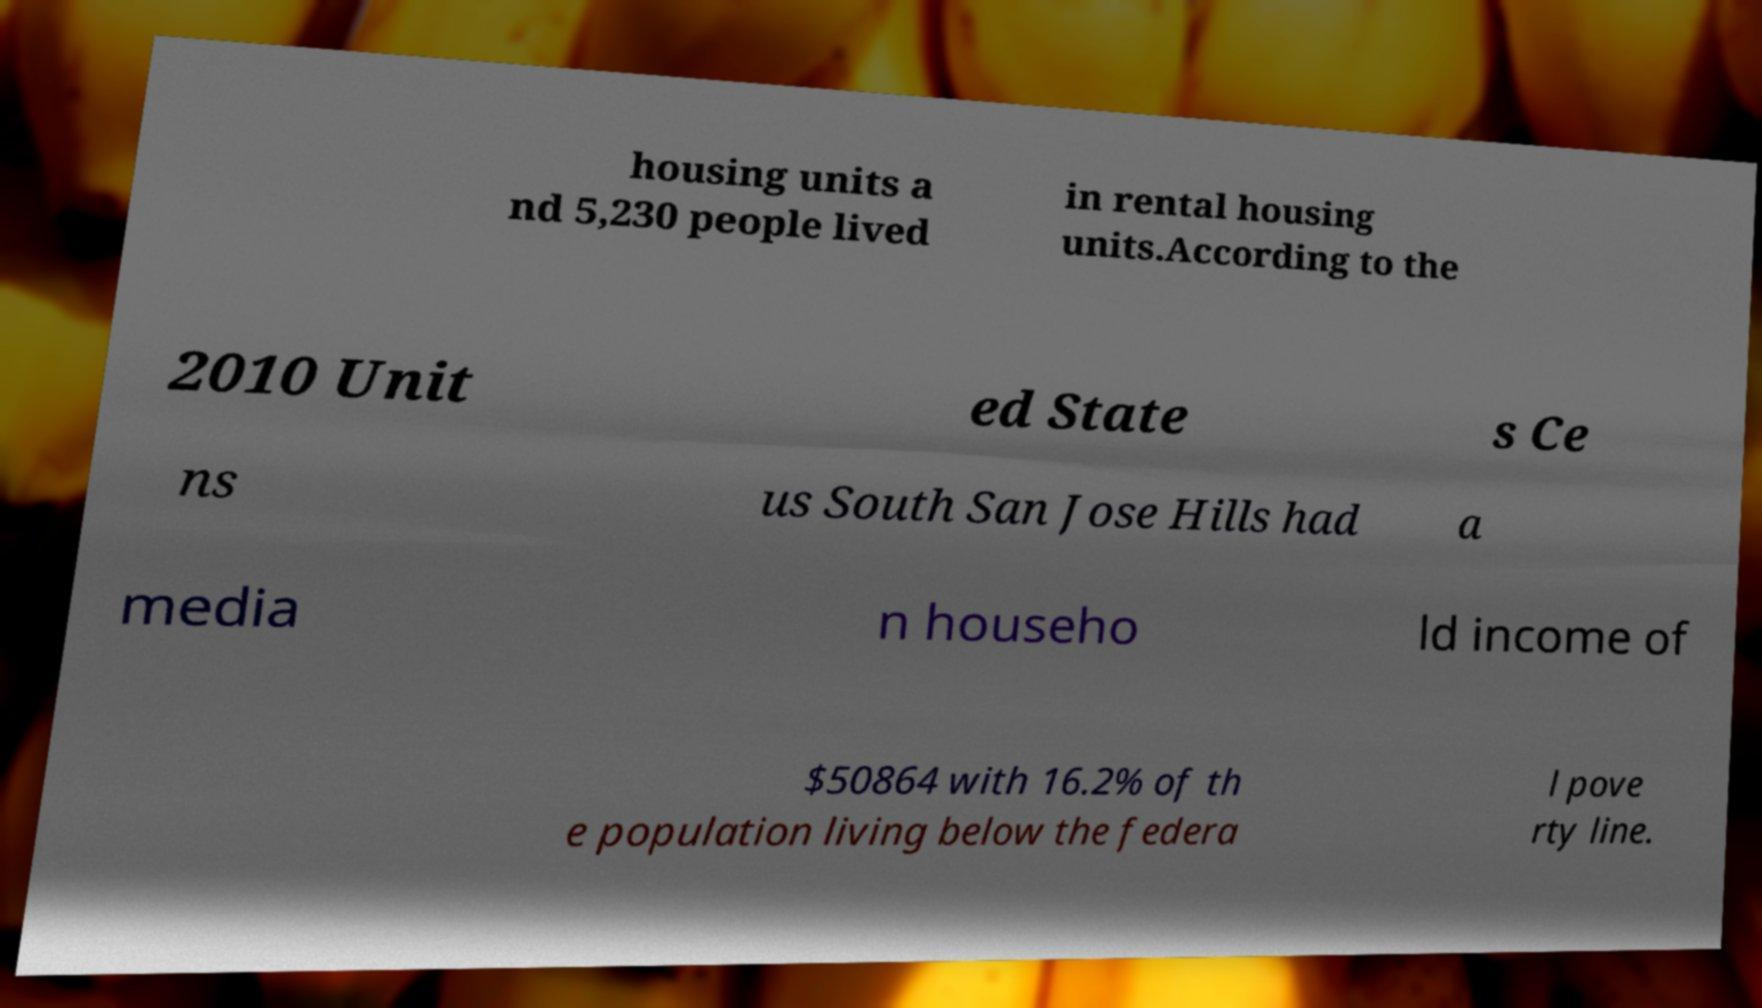What messages or text are displayed in this image? I need them in a readable, typed format. housing units a nd 5,230 people lived in rental housing units.According to the 2010 Unit ed State s Ce ns us South San Jose Hills had a media n househo ld income of $50864 with 16.2% of th e population living below the federa l pove rty line. 